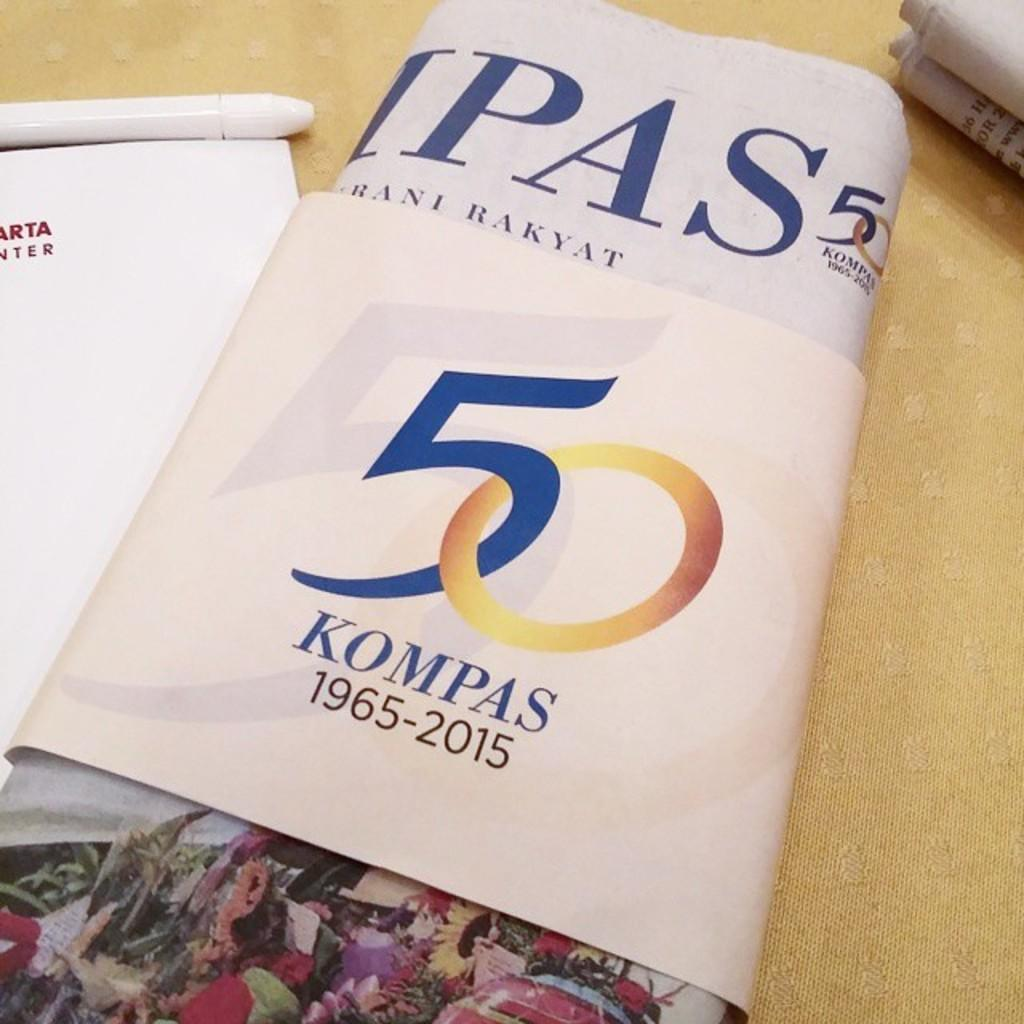<image>
Share a concise interpretation of the image provided. On a wood table there is a newsletter celebrating 50 years of something called "KOMPAS", during the years 1965-2015. 